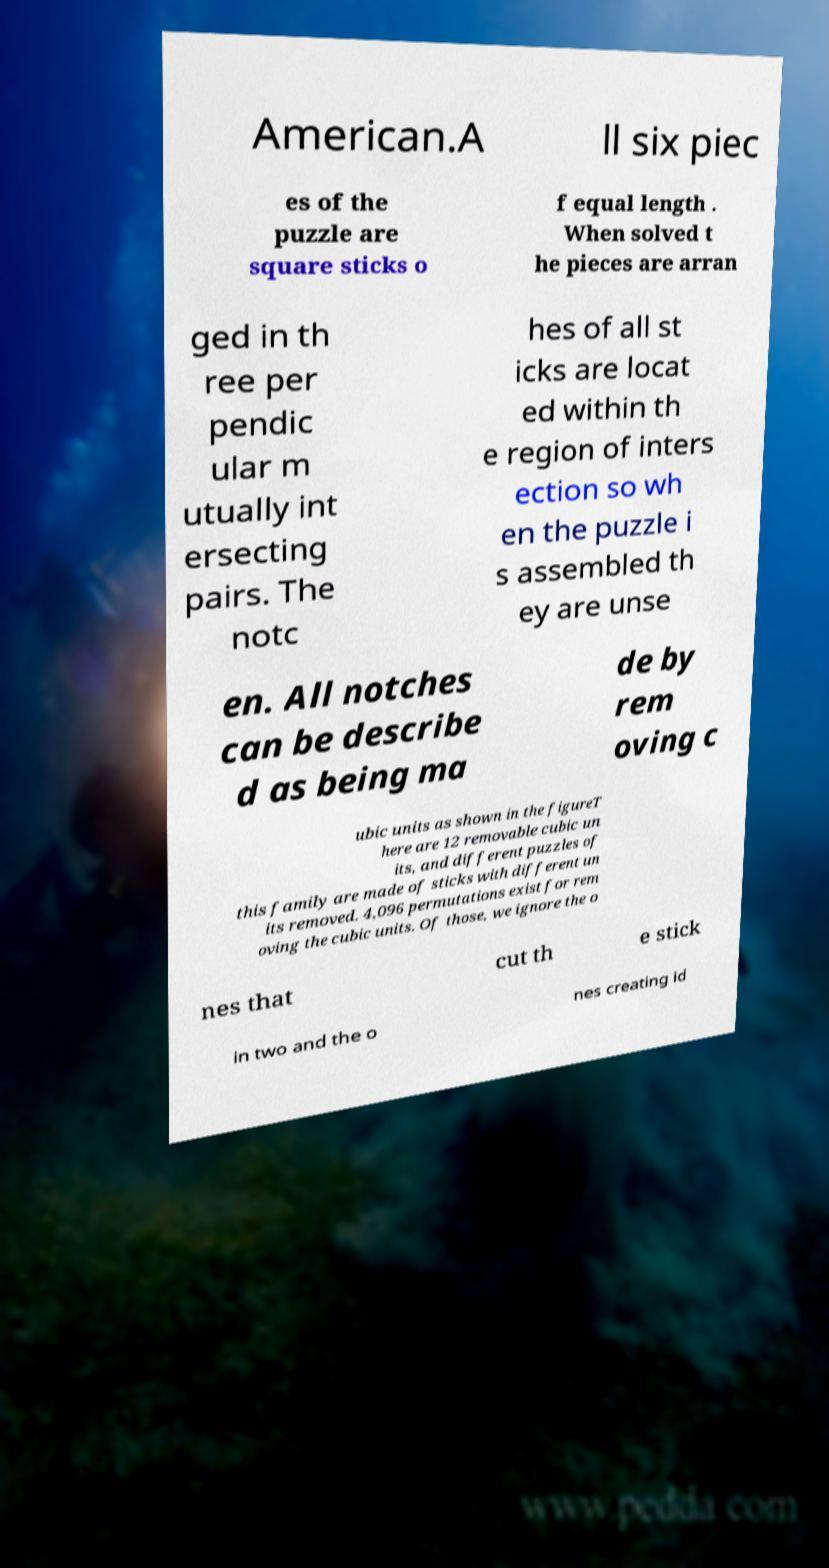There's text embedded in this image that I need extracted. Can you transcribe it verbatim? American.A ll six piec es of the puzzle are square sticks o f equal length . When solved t he pieces are arran ged in th ree per pendic ular m utually int ersecting pairs. The notc hes of all st icks are locat ed within th e region of inters ection so wh en the puzzle i s assembled th ey are unse en. All notches can be describe d as being ma de by rem oving c ubic units as shown in the figureT here are 12 removable cubic un its, and different puzzles of this family are made of sticks with different un its removed. 4,096 permutations exist for rem oving the cubic units. Of those, we ignore the o nes that cut th e stick in two and the o nes creating id 